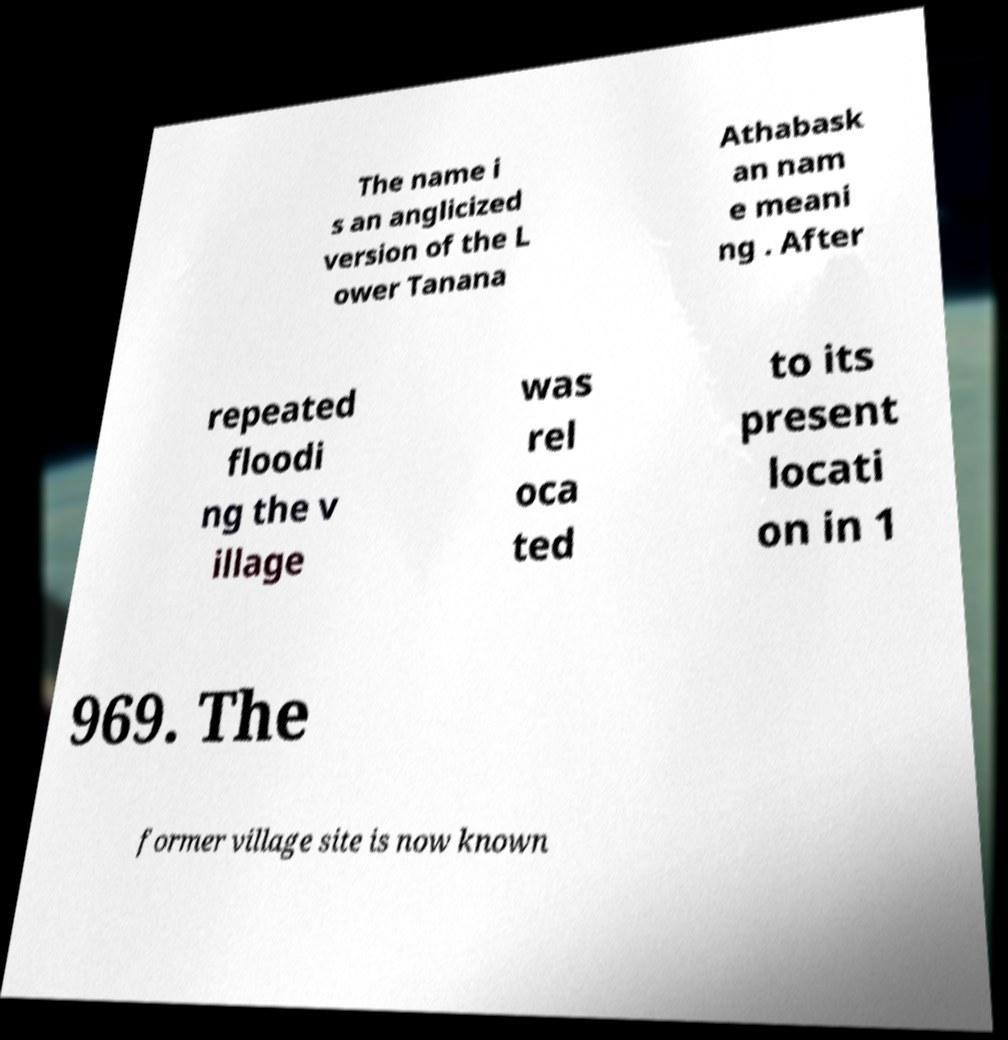Can you accurately transcribe the text from the provided image for me? The name i s an anglicized version of the L ower Tanana Athabask an nam e meani ng . After repeated floodi ng the v illage was rel oca ted to its present locati on in 1 969. The former village site is now known 